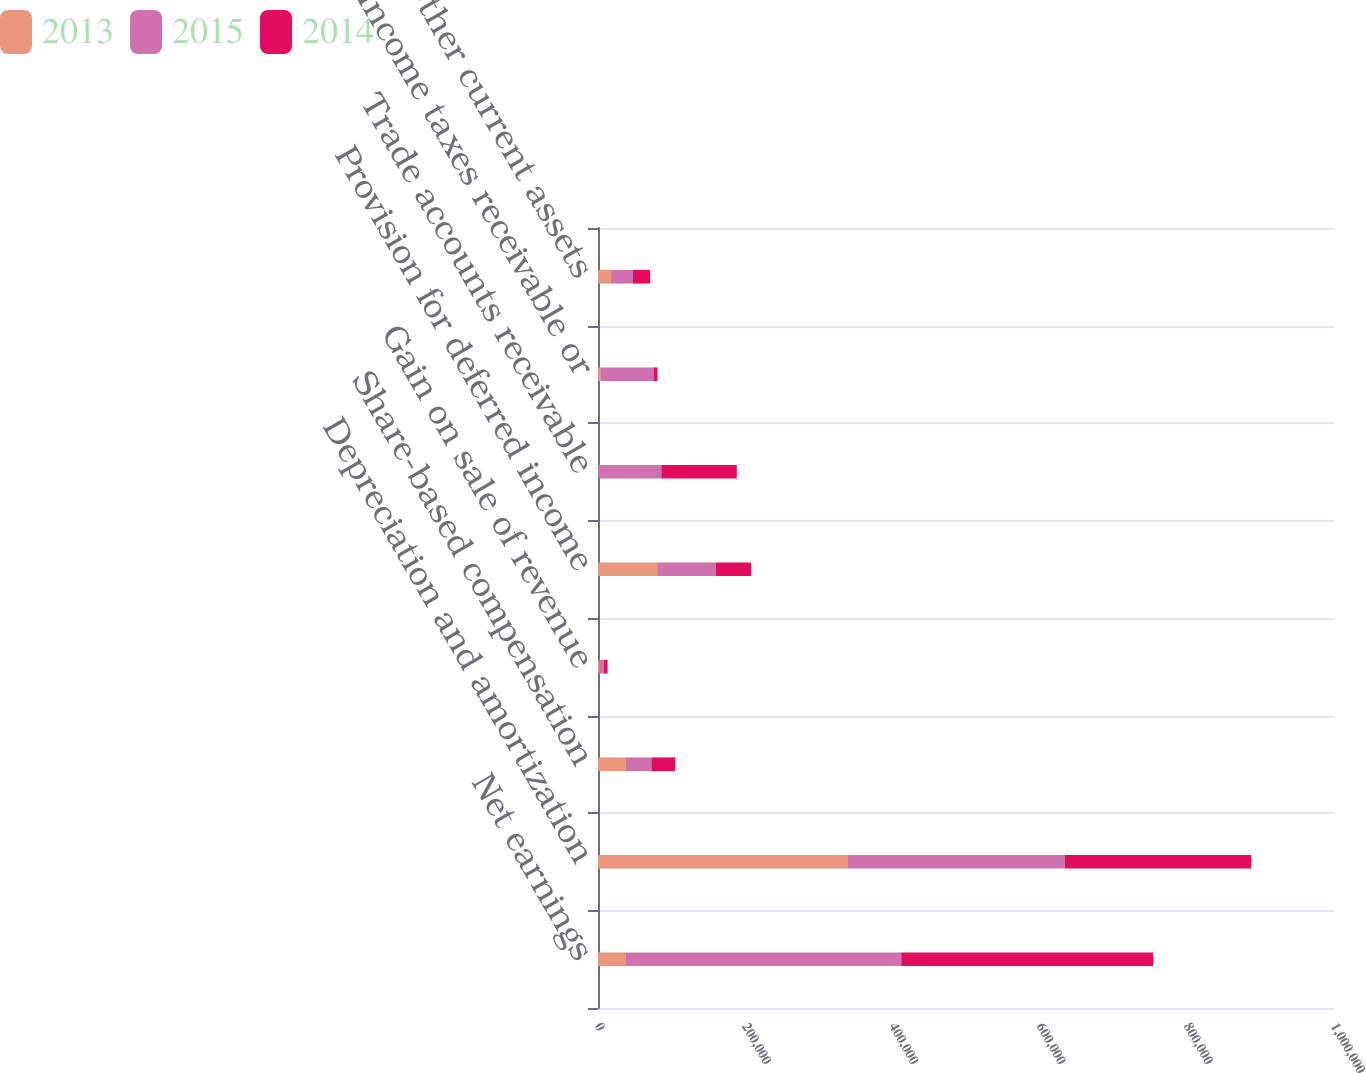Convert chart to OTSL. <chart><loc_0><loc_0><loc_500><loc_500><stacked_bar_chart><ecel><fcel>Net earnings<fcel>Depreciation and amortization<fcel>Share-based compensation<fcel>Gain on sale of revenue<fcel>Provision for deferred income<fcel>Trade accounts receivable<fcel>Income taxes receivable or<fcel>Other current assets<nl><fcel>2013<fcel>37228<fcel>339613<fcel>37228<fcel>1281<fcel>80427<fcel>747<fcel>3055<fcel>17735<nl><fcel>2015<fcel>374792<fcel>294496<fcel>35333<fcel>6342<fcel>79343<fcel>85276<fcel>72291<fcel>29793<nl><fcel>2014<fcel>342382<fcel>253380<fcel>32354<fcel>5334<fcel>48076<fcel>102508<fcel>5381<fcel>23254<nl></chart> 